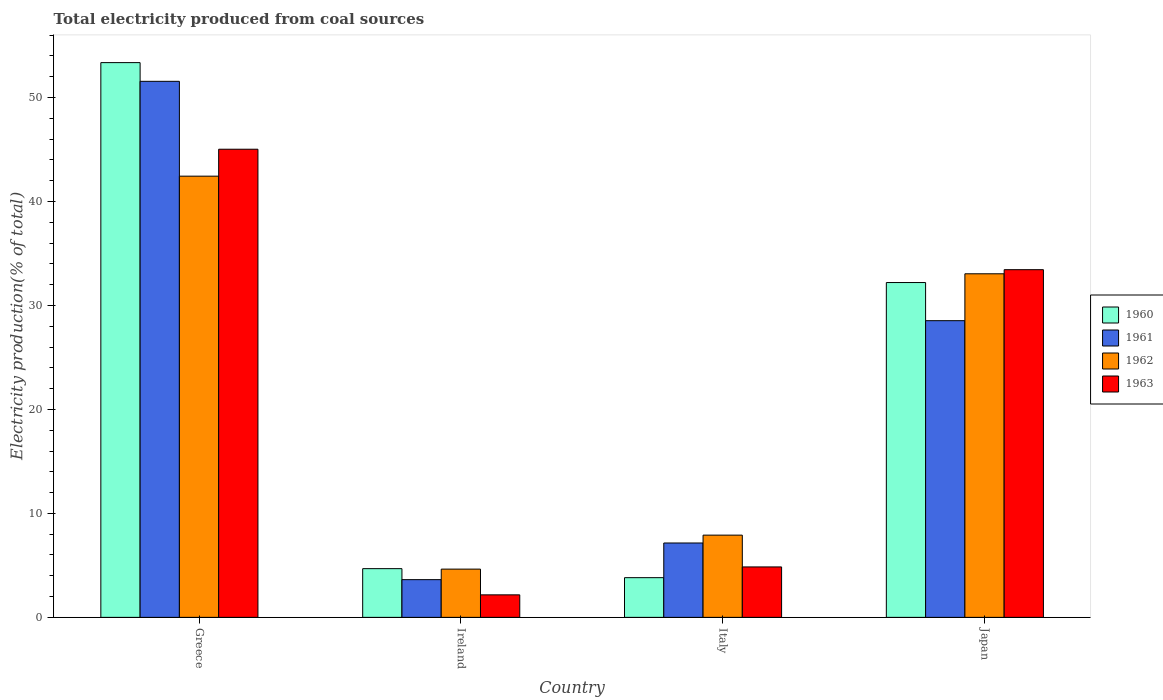How many different coloured bars are there?
Your answer should be very brief. 4. How many groups of bars are there?
Ensure brevity in your answer.  4. Are the number of bars per tick equal to the number of legend labels?
Your answer should be compact. Yes. Are the number of bars on each tick of the X-axis equal?
Your response must be concise. Yes. How many bars are there on the 1st tick from the left?
Your answer should be compact. 4. What is the label of the 4th group of bars from the left?
Offer a very short reply. Japan. What is the total electricity produced in 1962 in Italy?
Your answer should be very brief. 7.91. Across all countries, what is the maximum total electricity produced in 1961?
Offer a very short reply. 51.56. Across all countries, what is the minimum total electricity produced in 1962?
Provide a succinct answer. 4.64. In which country was the total electricity produced in 1961 minimum?
Give a very brief answer. Ireland. What is the total total electricity produced in 1963 in the graph?
Provide a succinct answer. 85.49. What is the difference between the total electricity produced in 1960 in Ireland and that in Italy?
Your answer should be very brief. 0.87. What is the difference between the total electricity produced in 1961 in Ireland and the total electricity produced in 1960 in Italy?
Provide a short and direct response. -0.19. What is the average total electricity produced in 1961 per country?
Keep it short and to the point. 22.72. What is the difference between the total electricity produced of/in 1961 and total electricity produced of/in 1962 in Ireland?
Offer a terse response. -1.01. What is the ratio of the total electricity produced in 1960 in Italy to that in Japan?
Offer a terse response. 0.12. Is the difference between the total electricity produced in 1961 in Ireland and Japan greater than the difference between the total electricity produced in 1962 in Ireland and Japan?
Provide a short and direct response. Yes. What is the difference between the highest and the second highest total electricity produced in 1960?
Provide a short and direct response. 27.52. What is the difference between the highest and the lowest total electricity produced in 1960?
Your answer should be very brief. 49.54. What does the 4th bar from the right in Japan represents?
Make the answer very short. 1960. How are the legend labels stacked?
Your response must be concise. Vertical. What is the title of the graph?
Your answer should be very brief. Total electricity produced from coal sources. Does "1991" appear as one of the legend labels in the graph?
Provide a short and direct response. No. What is the label or title of the X-axis?
Offer a terse response. Country. What is the label or title of the Y-axis?
Give a very brief answer. Electricity production(% of total). What is the Electricity production(% of total) of 1960 in Greece?
Your answer should be very brief. 53.36. What is the Electricity production(% of total) of 1961 in Greece?
Your answer should be compact. 51.56. What is the Electricity production(% of total) in 1962 in Greece?
Give a very brief answer. 42.44. What is the Electricity production(% of total) of 1963 in Greece?
Offer a very short reply. 45.03. What is the Electricity production(% of total) of 1960 in Ireland?
Provide a succinct answer. 4.69. What is the Electricity production(% of total) of 1961 in Ireland?
Ensure brevity in your answer.  3.63. What is the Electricity production(% of total) of 1962 in Ireland?
Your answer should be very brief. 4.64. What is the Electricity production(% of total) in 1963 in Ireland?
Your answer should be very brief. 2.16. What is the Electricity production(% of total) in 1960 in Italy?
Give a very brief answer. 3.82. What is the Electricity production(% of total) in 1961 in Italy?
Your answer should be very brief. 7.15. What is the Electricity production(% of total) in 1962 in Italy?
Your response must be concise. 7.91. What is the Electricity production(% of total) in 1963 in Italy?
Give a very brief answer. 4.85. What is the Electricity production(% of total) in 1960 in Japan?
Ensure brevity in your answer.  32.21. What is the Electricity production(% of total) in 1961 in Japan?
Keep it short and to the point. 28.54. What is the Electricity production(% of total) in 1962 in Japan?
Provide a succinct answer. 33.05. What is the Electricity production(% of total) in 1963 in Japan?
Offer a very short reply. 33.44. Across all countries, what is the maximum Electricity production(% of total) in 1960?
Ensure brevity in your answer.  53.36. Across all countries, what is the maximum Electricity production(% of total) in 1961?
Your answer should be very brief. 51.56. Across all countries, what is the maximum Electricity production(% of total) in 1962?
Provide a succinct answer. 42.44. Across all countries, what is the maximum Electricity production(% of total) of 1963?
Offer a terse response. 45.03. Across all countries, what is the minimum Electricity production(% of total) of 1960?
Your response must be concise. 3.82. Across all countries, what is the minimum Electricity production(% of total) of 1961?
Provide a short and direct response. 3.63. Across all countries, what is the minimum Electricity production(% of total) in 1962?
Provide a short and direct response. 4.64. Across all countries, what is the minimum Electricity production(% of total) in 1963?
Provide a succinct answer. 2.16. What is the total Electricity production(% of total) in 1960 in the graph?
Make the answer very short. 94.07. What is the total Electricity production(% of total) of 1961 in the graph?
Your response must be concise. 90.88. What is the total Electricity production(% of total) in 1962 in the graph?
Provide a succinct answer. 88.04. What is the total Electricity production(% of total) of 1963 in the graph?
Your answer should be compact. 85.49. What is the difference between the Electricity production(% of total) of 1960 in Greece and that in Ireland?
Ensure brevity in your answer.  48.68. What is the difference between the Electricity production(% of total) in 1961 in Greece and that in Ireland?
Ensure brevity in your answer.  47.93. What is the difference between the Electricity production(% of total) in 1962 in Greece and that in Ireland?
Ensure brevity in your answer.  37.8. What is the difference between the Electricity production(% of total) of 1963 in Greece and that in Ireland?
Provide a short and direct response. 42.87. What is the difference between the Electricity production(% of total) of 1960 in Greece and that in Italy?
Provide a short and direct response. 49.54. What is the difference between the Electricity production(% of total) in 1961 in Greece and that in Italy?
Your answer should be very brief. 44.41. What is the difference between the Electricity production(% of total) of 1962 in Greece and that in Italy?
Give a very brief answer. 34.53. What is the difference between the Electricity production(% of total) of 1963 in Greece and that in Italy?
Give a very brief answer. 40.18. What is the difference between the Electricity production(% of total) of 1960 in Greece and that in Japan?
Provide a succinct answer. 21.15. What is the difference between the Electricity production(% of total) in 1961 in Greece and that in Japan?
Keep it short and to the point. 23.02. What is the difference between the Electricity production(% of total) of 1962 in Greece and that in Japan?
Provide a succinct answer. 9.39. What is the difference between the Electricity production(% of total) of 1963 in Greece and that in Japan?
Make the answer very short. 11.59. What is the difference between the Electricity production(% of total) of 1960 in Ireland and that in Italy?
Make the answer very short. 0.87. What is the difference between the Electricity production(% of total) of 1961 in Ireland and that in Italy?
Provide a short and direct response. -3.53. What is the difference between the Electricity production(% of total) in 1962 in Ireland and that in Italy?
Your answer should be compact. -3.27. What is the difference between the Electricity production(% of total) in 1963 in Ireland and that in Italy?
Keep it short and to the point. -2.69. What is the difference between the Electricity production(% of total) in 1960 in Ireland and that in Japan?
Your answer should be compact. -27.52. What is the difference between the Electricity production(% of total) of 1961 in Ireland and that in Japan?
Provide a short and direct response. -24.91. What is the difference between the Electricity production(% of total) of 1962 in Ireland and that in Japan?
Keep it short and to the point. -28.41. What is the difference between the Electricity production(% of total) in 1963 in Ireland and that in Japan?
Ensure brevity in your answer.  -31.28. What is the difference between the Electricity production(% of total) of 1960 in Italy and that in Japan?
Provide a succinct answer. -28.39. What is the difference between the Electricity production(% of total) of 1961 in Italy and that in Japan?
Offer a very short reply. -21.38. What is the difference between the Electricity production(% of total) of 1962 in Italy and that in Japan?
Your response must be concise. -25.14. What is the difference between the Electricity production(% of total) in 1963 in Italy and that in Japan?
Your answer should be very brief. -28.59. What is the difference between the Electricity production(% of total) of 1960 in Greece and the Electricity production(% of total) of 1961 in Ireland?
Give a very brief answer. 49.73. What is the difference between the Electricity production(% of total) in 1960 in Greece and the Electricity production(% of total) in 1962 in Ireland?
Ensure brevity in your answer.  48.72. What is the difference between the Electricity production(% of total) in 1960 in Greece and the Electricity production(% of total) in 1963 in Ireland?
Your answer should be compact. 51.2. What is the difference between the Electricity production(% of total) in 1961 in Greece and the Electricity production(% of total) in 1962 in Ireland?
Offer a terse response. 46.92. What is the difference between the Electricity production(% of total) of 1961 in Greece and the Electricity production(% of total) of 1963 in Ireland?
Give a very brief answer. 49.4. What is the difference between the Electricity production(% of total) of 1962 in Greece and the Electricity production(% of total) of 1963 in Ireland?
Offer a very short reply. 40.27. What is the difference between the Electricity production(% of total) of 1960 in Greece and the Electricity production(% of total) of 1961 in Italy?
Give a very brief answer. 46.21. What is the difference between the Electricity production(% of total) of 1960 in Greece and the Electricity production(% of total) of 1962 in Italy?
Keep it short and to the point. 45.45. What is the difference between the Electricity production(% of total) of 1960 in Greece and the Electricity production(% of total) of 1963 in Italy?
Your answer should be compact. 48.51. What is the difference between the Electricity production(% of total) in 1961 in Greece and the Electricity production(% of total) in 1962 in Italy?
Your response must be concise. 43.65. What is the difference between the Electricity production(% of total) in 1961 in Greece and the Electricity production(% of total) in 1963 in Italy?
Your answer should be very brief. 46.71. What is the difference between the Electricity production(% of total) in 1962 in Greece and the Electricity production(% of total) in 1963 in Italy?
Keep it short and to the point. 37.59. What is the difference between the Electricity production(% of total) of 1960 in Greece and the Electricity production(% of total) of 1961 in Japan?
Your answer should be compact. 24.82. What is the difference between the Electricity production(% of total) of 1960 in Greece and the Electricity production(% of total) of 1962 in Japan?
Offer a terse response. 20.31. What is the difference between the Electricity production(% of total) of 1960 in Greece and the Electricity production(% of total) of 1963 in Japan?
Ensure brevity in your answer.  19.92. What is the difference between the Electricity production(% of total) of 1961 in Greece and the Electricity production(% of total) of 1962 in Japan?
Offer a very short reply. 18.51. What is the difference between the Electricity production(% of total) in 1961 in Greece and the Electricity production(% of total) in 1963 in Japan?
Your response must be concise. 18.12. What is the difference between the Electricity production(% of total) in 1962 in Greece and the Electricity production(% of total) in 1963 in Japan?
Your response must be concise. 9. What is the difference between the Electricity production(% of total) in 1960 in Ireland and the Electricity production(% of total) in 1961 in Italy?
Offer a very short reply. -2.47. What is the difference between the Electricity production(% of total) in 1960 in Ireland and the Electricity production(% of total) in 1962 in Italy?
Offer a terse response. -3.22. What is the difference between the Electricity production(% of total) in 1960 in Ireland and the Electricity production(% of total) in 1963 in Italy?
Your answer should be very brief. -0.17. What is the difference between the Electricity production(% of total) in 1961 in Ireland and the Electricity production(% of total) in 1962 in Italy?
Make the answer very short. -4.28. What is the difference between the Electricity production(% of total) in 1961 in Ireland and the Electricity production(% of total) in 1963 in Italy?
Offer a very short reply. -1.22. What is the difference between the Electricity production(% of total) in 1962 in Ireland and the Electricity production(% of total) in 1963 in Italy?
Provide a short and direct response. -0.21. What is the difference between the Electricity production(% of total) of 1960 in Ireland and the Electricity production(% of total) of 1961 in Japan?
Your answer should be very brief. -23.85. What is the difference between the Electricity production(% of total) in 1960 in Ireland and the Electricity production(% of total) in 1962 in Japan?
Give a very brief answer. -28.36. What is the difference between the Electricity production(% of total) in 1960 in Ireland and the Electricity production(% of total) in 1963 in Japan?
Offer a very short reply. -28.76. What is the difference between the Electricity production(% of total) in 1961 in Ireland and the Electricity production(% of total) in 1962 in Japan?
Your response must be concise. -29.42. What is the difference between the Electricity production(% of total) in 1961 in Ireland and the Electricity production(% of total) in 1963 in Japan?
Offer a very short reply. -29.82. What is the difference between the Electricity production(% of total) of 1962 in Ireland and the Electricity production(% of total) of 1963 in Japan?
Make the answer very short. -28.8. What is the difference between the Electricity production(% of total) in 1960 in Italy and the Electricity production(% of total) in 1961 in Japan?
Ensure brevity in your answer.  -24.72. What is the difference between the Electricity production(% of total) of 1960 in Italy and the Electricity production(% of total) of 1962 in Japan?
Your response must be concise. -29.23. What is the difference between the Electricity production(% of total) in 1960 in Italy and the Electricity production(% of total) in 1963 in Japan?
Offer a terse response. -29.63. What is the difference between the Electricity production(% of total) of 1961 in Italy and the Electricity production(% of total) of 1962 in Japan?
Give a very brief answer. -25.89. What is the difference between the Electricity production(% of total) of 1961 in Italy and the Electricity production(% of total) of 1963 in Japan?
Make the answer very short. -26.29. What is the difference between the Electricity production(% of total) in 1962 in Italy and the Electricity production(% of total) in 1963 in Japan?
Your response must be concise. -25.53. What is the average Electricity production(% of total) in 1960 per country?
Your response must be concise. 23.52. What is the average Electricity production(% of total) of 1961 per country?
Provide a succinct answer. 22.72. What is the average Electricity production(% of total) in 1962 per country?
Keep it short and to the point. 22.01. What is the average Electricity production(% of total) in 1963 per country?
Offer a terse response. 21.37. What is the difference between the Electricity production(% of total) in 1960 and Electricity production(% of total) in 1961 in Greece?
Offer a terse response. 1.8. What is the difference between the Electricity production(% of total) of 1960 and Electricity production(% of total) of 1962 in Greece?
Ensure brevity in your answer.  10.92. What is the difference between the Electricity production(% of total) of 1960 and Electricity production(% of total) of 1963 in Greece?
Your answer should be very brief. 8.33. What is the difference between the Electricity production(% of total) of 1961 and Electricity production(% of total) of 1962 in Greece?
Offer a terse response. 9.12. What is the difference between the Electricity production(% of total) in 1961 and Electricity production(% of total) in 1963 in Greece?
Offer a very short reply. 6.53. What is the difference between the Electricity production(% of total) of 1962 and Electricity production(% of total) of 1963 in Greece?
Your answer should be compact. -2.59. What is the difference between the Electricity production(% of total) in 1960 and Electricity production(% of total) in 1961 in Ireland?
Give a very brief answer. 1.06. What is the difference between the Electricity production(% of total) of 1960 and Electricity production(% of total) of 1962 in Ireland?
Offer a terse response. 0.05. What is the difference between the Electricity production(% of total) in 1960 and Electricity production(% of total) in 1963 in Ireland?
Your response must be concise. 2.52. What is the difference between the Electricity production(% of total) of 1961 and Electricity production(% of total) of 1962 in Ireland?
Make the answer very short. -1.01. What is the difference between the Electricity production(% of total) in 1961 and Electricity production(% of total) in 1963 in Ireland?
Your answer should be compact. 1.46. What is the difference between the Electricity production(% of total) in 1962 and Electricity production(% of total) in 1963 in Ireland?
Provide a succinct answer. 2.48. What is the difference between the Electricity production(% of total) in 1960 and Electricity production(% of total) in 1961 in Italy?
Keep it short and to the point. -3.34. What is the difference between the Electricity production(% of total) in 1960 and Electricity production(% of total) in 1962 in Italy?
Make the answer very short. -4.09. What is the difference between the Electricity production(% of total) of 1960 and Electricity production(% of total) of 1963 in Italy?
Make the answer very short. -1.03. What is the difference between the Electricity production(% of total) of 1961 and Electricity production(% of total) of 1962 in Italy?
Make the answer very short. -0.75. What is the difference between the Electricity production(% of total) of 1961 and Electricity production(% of total) of 1963 in Italy?
Provide a short and direct response. 2.3. What is the difference between the Electricity production(% of total) of 1962 and Electricity production(% of total) of 1963 in Italy?
Your answer should be very brief. 3.06. What is the difference between the Electricity production(% of total) in 1960 and Electricity production(% of total) in 1961 in Japan?
Make the answer very short. 3.67. What is the difference between the Electricity production(% of total) of 1960 and Electricity production(% of total) of 1962 in Japan?
Ensure brevity in your answer.  -0.84. What is the difference between the Electricity production(% of total) in 1960 and Electricity production(% of total) in 1963 in Japan?
Ensure brevity in your answer.  -1.24. What is the difference between the Electricity production(% of total) in 1961 and Electricity production(% of total) in 1962 in Japan?
Keep it short and to the point. -4.51. What is the difference between the Electricity production(% of total) in 1961 and Electricity production(% of total) in 1963 in Japan?
Keep it short and to the point. -4.9. What is the difference between the Electricity production(% of total) in 1962 and Electricity production(% of total) in 1963 in Japan?
Give a very brief answer. -0.4. What is the ratio of the Electricity production(% of total) in 1960 in Greece to that in Ireland?
Offer a very short reply. 11.39. What is the ratio of the Electricity production(% of total) in 1961 in Greece to that in Ireland?
Make the answer very short. 14.21. What is the ratio of the Electricity production(% of total) of 1962 in Greece to that in Ireland?
Offer a very short reply. 9.14. What is the ratio of the Electricity production(% of total) of 1963 in Greece to that in Ireland?
Your answer should be compact. 20.8. What is the ratio of the Electricity production(% of total) in 1960 in Greece to that in Italy?
Make the answer very short. 13.97. What is the ratio of the Electricity production(% of total) of 1961 in Greece to that in Italy?
Your answer should be very brief. 7.21. What is the ratio of the Electricity production(% of total) of 1962 in Greece to that in Italy?
Your response must be concise. 5.37. What is the ratio of the Electricity production(% of total) in 1963 in Greece to that in Italy?
Ensure brevity in your answer.  9.28. What is the ratio of the Electricity production(% of total) of 1960 in Greece to that in Japan?
Give a very brief answer. 1.66. What is the ratio of the Electricity production(% of total) of 1961 in Greece to that in Japan?
Your answer should be very brief. 1.81. What is the ratio of the Electricity production(% of total) in 1962 in Greece to that in Japan?
Offer a very short reply. 1.28. What is the ratio of the Electricity production(% of total) of 1963 in Greece to that in Japan?
Provide a short and direct response. 1.35. What is the ratio of the Electricity production(% of total) in 1960 in Ireland to that in Italy?
Keep it short and to the point. 1.23. What is the ratio of the Electricity production(% of total) in 1961 in Ireland to that in Italy?
Provide a succinct answer. 0.51. What is the ratio of the Electricity production(% of total) of 1962 in Ireland to that in Italy?
Make the answer very short. 0.59. What is the ratio of the Electricity production(% of total) in 1963 in Ireland to that in Italy?
Make the answer very short. 0.45. What is the ratio of the Electricity production(% of total) in 1960 in Ireland to that in Japan?
Keep it short and to the point. 0.15. What is the ratio of the Electricity production(% of total) of 1961 in Ireland to that in Japan?
Keep it short and to the point. 0.13. What is the ratio of the Electricity production(% of total) of 1962 in Ireland to that in Japan?
Provide a succinct answer. 0.14. What is the ratio of the Electricity production(% of total) in 1963 in Ireland to that in Japan?
Ensure brevity in your answer.  0.06. What is the ratio of the Electricity production(% of total) of 1960 in Italy to that in Japan?
Your answer should be compact. 0.12. What is the ratio of the Electricity production(% of total) of 1961 in Italy to that in Japan?
Offer a very short reply. 0.25. What is the ratio of the Electricity production(% of total) of 1962 in Italy to that in Japan?
Ensure brevity in your answer.  0.24. What is the ratio of the Electricity production(% of total) in 1963 in Italy to that in Japan?
Offer a very short reply. 0.15. What is the difference between the highest and the second highest Electricity production(% of total) in 1960?
Give a very brief answer. 21.15. What is the difference between the highest and the second highest Electricity production(% of total) of 1961?
Provide a succinct answer. 23.02. What is the difference between the highest and the second highest Electricity production(% of total) of 1962?
Your response must be concise. 9.39. What is the difference between the highest and the second highest Electricity production(% of total) of 1963?
Provide a succinct answer. 11.59. What is the difference between the highest and the lowest Electricity production(% of total) of 1960?
Make the answer very short. 49.54. What is the difference between the highest and the lowest Electricity production(% of total) of 1961?
Your answer should be very brief. 47.93. What is the difference between the highest and the lowest Electricity production(% of total) of 1962?
Your answer should be compact. 37.8. What is the difference between the highest and the lowest Electricity production(% of total) of 1963?
Offer a very short reply. 42.87. 